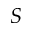Convert formula to latex. <formula><loc_0><loc_0><loc_500><loc_500>S</formula> 